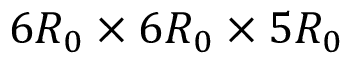Convert formula to latex. <formula><loc_0><loc_0><loc_500><loc_500>6 { R _ { 0 } } \times 6 { R _ { 0 } } \times 5 { R _ { 0 } }</formula> 